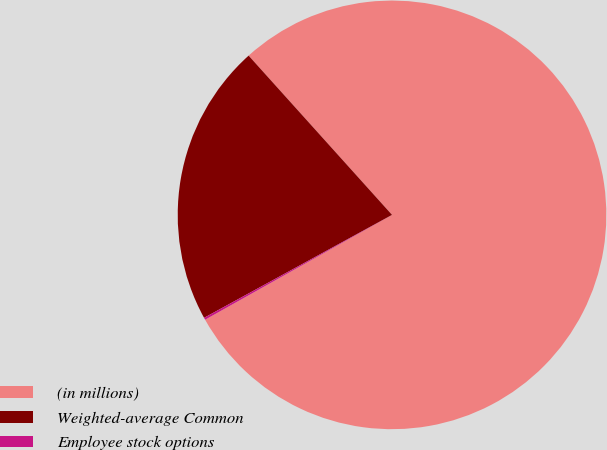Convert chart. <chart><loc_0><loc_0><loc_500><loc_500><pie_chart><fcel>(in millions)<fcel>Weighted-average Common<fcel>Employee stock options<nl><fcel>78.54%<fcel>21.31%<fcel>0.16%<nl></chart> 